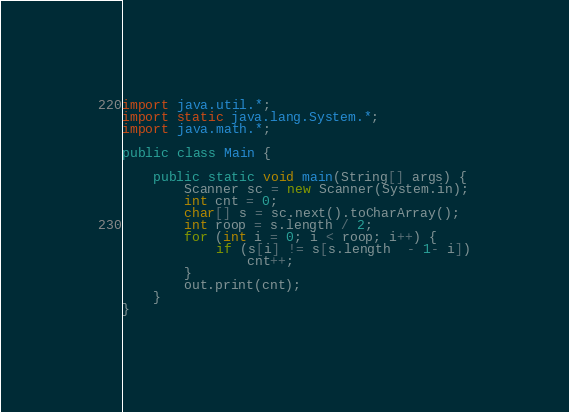<code> <loc_0><loc_0><loc_500><loc_500><_Java_>import java.util.*;
import static java.lang.System.*;
import java.math.*;

public class Main {

	public static void main(String[] args) {
		Scanner sc = new Scanner(System.in);
		int cnt = 0;
		char[] s = sc.next().toCharArray();
		int roop = s.length / 2;
		for (int i = 0; i < roop; i++) {
			if (s[i] != s[s.length  - 1- i])
				cnt++;
		}
		out.print(cnt);
	}
}</code> 